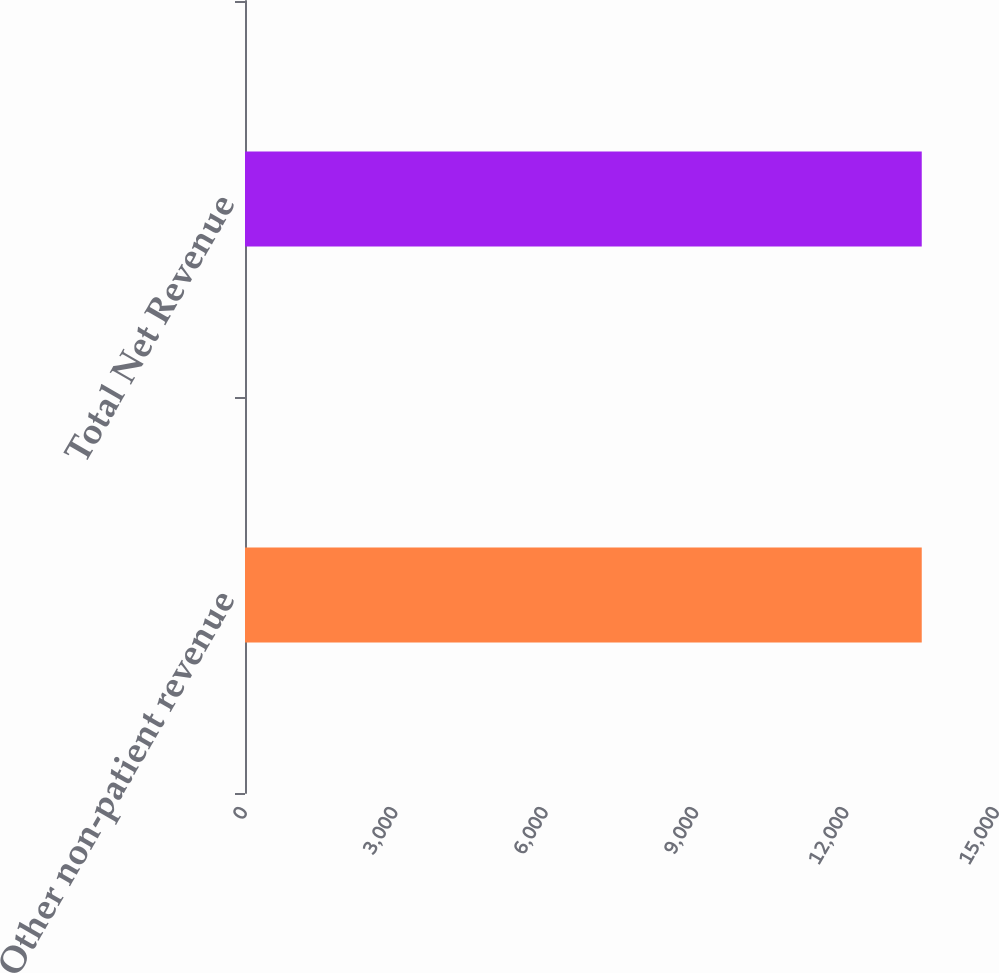Convert chart. <chart><loc_0><loc_0><loc_500><loc_500><bar_chart><fcel>Other non-patient revenue<fcel>Total Net Revenue<nl><fcel>13499<fcel>13499.1<nl></chart> 